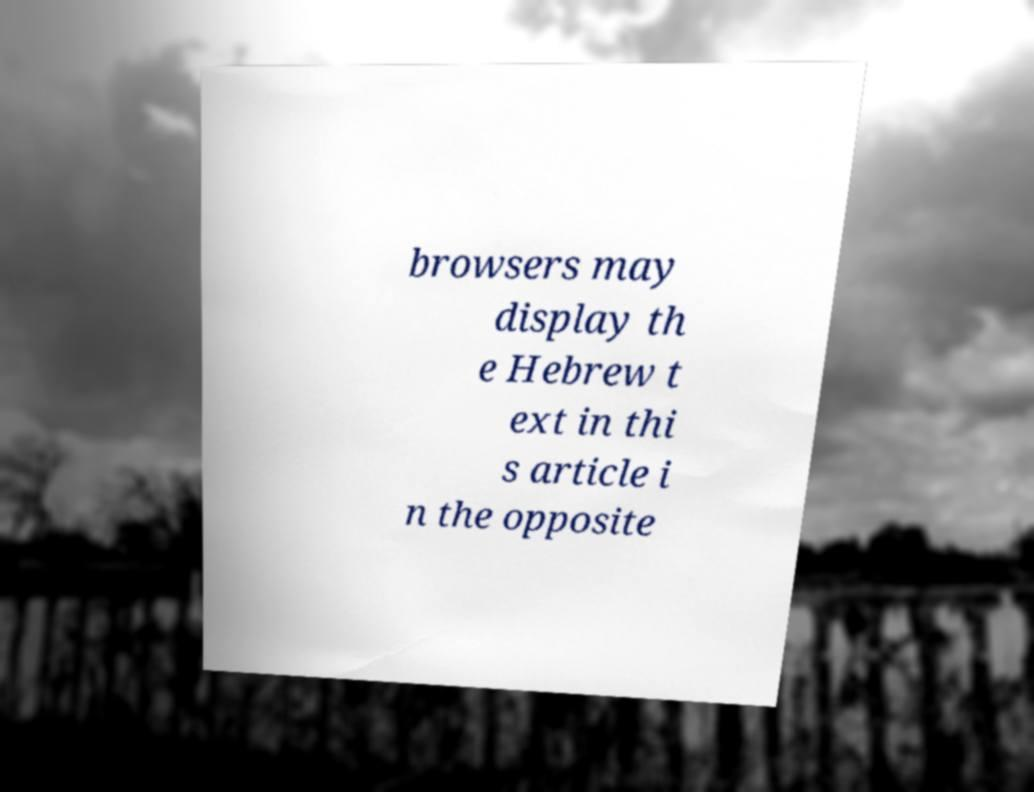Could you extract and type out the text from this image? browsers may display th e Hebrew t ext in thi s article i n the opposite 